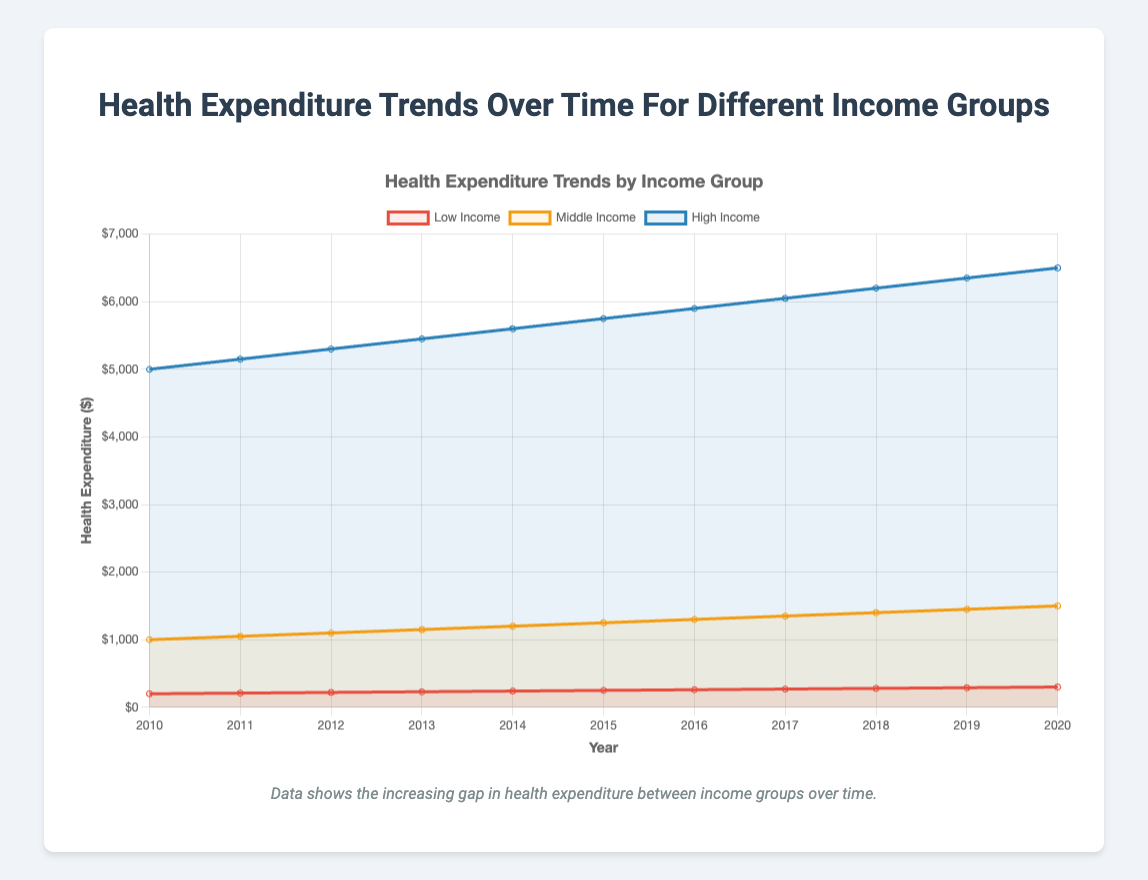Which income group has the highest health expenditure in 2020? The line representing the high-income group is at the highest position in 2020, with a value of $6500. The middle and low-income groups are below this, with $1500 and $300 respectively.
Answer: High-income What is the overall trend of health expenditures for the low-income group from 2010 to 2020? The line for the low-income group consistently increases from $200 in 2010 to $300 in 2020, indicating an upward trend.
Answer: Upward trend How much did the health expenditure increase for the middle-income group from 2010 to 2015? The middle-income group's health expenditure in 2010 was $1000 and in 2015, it was $1250. The increase is $1250 - $1000 = $250.
Answer: $250 What is the average health expenditure for the high-income group over the period 2010-2020? Sum the expenditures: 5000 + 5150 + 5300 + 5450 + 5600 + 5750 + 5900 + 6050 + 6200 + 6350 + 6500 = 63250. Divide by the number of years (11): 63250 / 11 = 5750.
Answer: $5750 Which year shows the smallest difference in health expenditures between the high-income and low-income groups? Calculate the annual differences: 2010 (4800), 2011 (4940), 2012 (5080), 2013 (5220), 2014 (5360), 2015 (5500), 2016 (5640), 2017 (5780), 2018 (5920), 2019 (6060), 2020 (6200). The smallest difference is in 2010.
Answer: 2010 Compare the steepness of the trend lines for low-income and high-income groups. The slope of the high-income group's line is steeper because the expenditure increases from $5000 to $6500 (gain of $1500) from 2010 to 2020, versus the low-income group's increase from $200 to $300 (gain of $100).
Answer: High-income steeper What is the combined health expenditure for all income groups in 2014? Add the expenditures: low-income ($240) + middle-income ($1200) + high-income ($5600) = $7040.
Answer: $7040 What is the rate of increase in health expenditure for the middle-income group from 2019 to 2020? The expenditure for 2019 was $1450 and for 2020 it was $1500. The rate of increase = (1500 - 1450) / 1450 = 0.0345 or 3.45%.
Answer: 3.45% In which year did the middle-income group reach $1300 in health expenditure? Look at the plot for the middle-income group line which reaches $1300 in 2016.
Answer: 2016 How does the visual representation (color, position) help identify different income groups? The low-income group is red, middle-income is orange, and high-income is blue. The color and vertical position on the y-axis distinguish the groups.
Answer: Color and position 